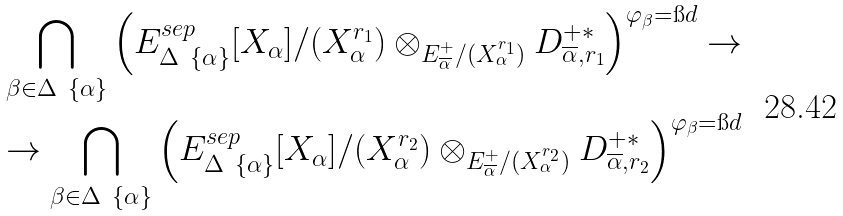Convert formula to latex. <formula><loc_0><loc_0><loc_500><loc_500>\bigcap _ { \beta \in \Delta \ \{ \alpha \} } \left ( E ^ { s e p } _ { \Delta \ \{ \alpha \} } [ X _ { \alpha } ] / ( X _ { \alpha } ^ { r _ { 1 } } ) \otimes _ { E ^ { + } _ { \overline { \alpha } } / ( X _ { \alpha } ^ { r _ { 1 } } ) } D ^ { + * } _ { \overline { \alpha } , r _ { 1 } } \right ) ^ { \varphi _ { \beta } = \i d } \to \\ \to \bigcap _ { \beta \in \Delta \ \{ \alpha \} } \left ( E ^ { s e p } _ { \Delta \ \{ \alpha \} } [ X _ { \alpha } ] / ( X _ { \alpha } ^ { r _ { 2 } } ) \otimes _ { E ^ { + } _ { \overline { \alpha } } / ( X _ { \alpha } ^ { r _ { 2 } } ) } D ^ { + * } _ { \overline { \alpha } , r _ { 2 } } \right ) ^ { \varphi _ { \beta } = \i d }</formula> 